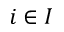Convert formula to latex. <formula><loc_0><loc_0><loc_500><loc_500>i \in I</formula> 